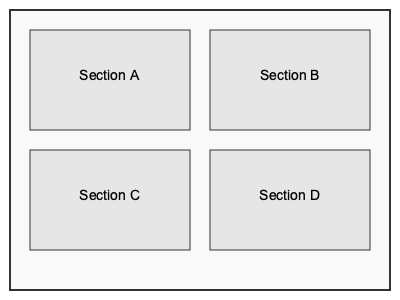Which layout arrangement for a bakery/cafe menu board would create the most visually balanced and appealing design? To create a visually balanced and appealing menu board design, we need to consider the following principles:

1. Symmetry: The layout should have a balanced distribution of elements on both sides.
2. Grouping: Similar items should be grouped together for easy navigation.
3. White space: Adequate space between sections helps prevent visual clutter.
4. Hierarchy: Important information should be more prominent.

Analyzing the given layout:

1. The design is symmetrical, with four equal-sized sections arranged in a 2x2 grid.
2. Each section (A, B, C, D) can represent a different category of menu items (e.g., A: Pastries, B: Beverages, C: Sandwiches, D: Specials).
3. There is sufficient white space between sections and around the edges of the board.
4. The equal size of sections allows for flexibility in emphasizing different categories as needed.

This layout achieves visual balance through:
- Even distribution of sections
- Consistent spacing
- Clear separation of categories

For a bakery/cafe, this arrangement allows customers to quickly find items of interest and makes it easy to update or rotate menu items within each section.
Answer: 2x2 grid layout 